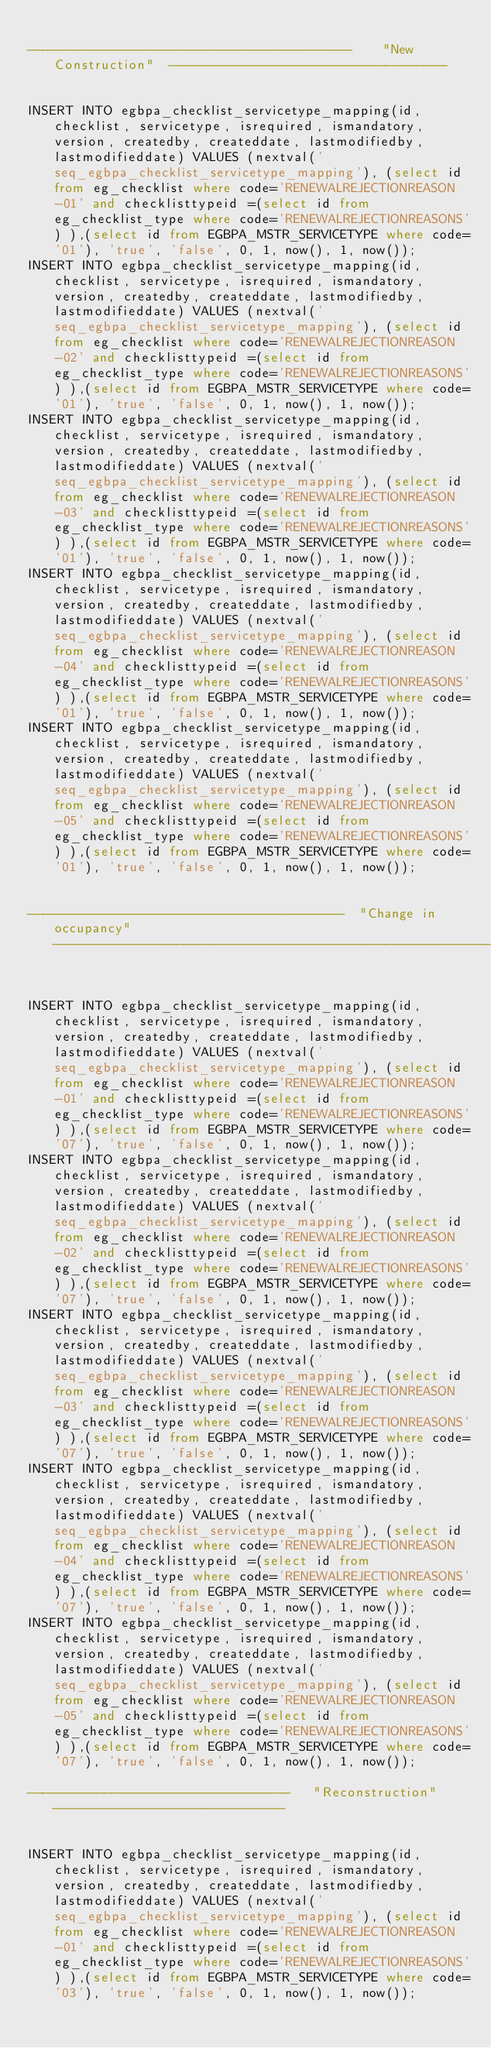Convert code to text. <code><loc_0><loc_0><loc_500><loc_500><_SQL_>
------------------------------------------    "New Construction"  ------------------------------------


INSERT INTO egbpa_checklist_servicetype_mapping(id, checklist, servicetype, isrequired, ismandatory, version, createdby, createddate, lastmodifiedby,lastmodifieddate) VALUES (nextval('seq_egbpa_checklist_servicetype_mapping'), (select id from eg_checklist where code='RENEWALREJECTIONREASON-01' and checklisttypeid =(select id from eg_checklist_type where code='RENEWALREJECTIONREASONS') ),(select id from EGBPA_MSTR_SERVICETYPE where code='01'), 'true', 'false', 0, 1, now(), 1, now());
INSERT INTO egbpa_checklist_servicetype_mapping(id, checklist, servicetype, isrequired, ismandatory, version, createdby, createddate, lastmodifiedby,lastmodifieddate) VALUES (nextval('seq_egbpa_checklist_servicetype_mapping'), (select id from eg_checklist where code='RENEWALREJECTIONREASON-02' and checklisttypeid =(select id from eg_checklist_type where code='RENEWALREJECTIONREASONS') ),(select id from EGBPA_MSTR_SERVICETYPE where code='01'), 'true', 'false', 0, 1, now(), 1, now());
INSERT INTO egbpa_checklist_servicetype_mapping(id, checklist, servicetype, isrequired, ismandatory, version, createdby, createddate, lastmodifiedby,lastmodifieddate) VALUES (nextval('seq_egbpa_checklist_servicetype_mapping'), (select id from eg_checklist where code='RENEWALREJECTIONREASON-03' and checklisttypeid =(select id from eg_checklist_type where code='RENEWALREJECTIONREASONS') ),(select id from EGBPA_MSTR_SERVICETYPE where code='01'), 'true', 'false', 0, 1, now(), 1, now());
INSERT INTO egbpa_checklist_servicetype_mapping(id, checklist, servicetype, isrequired, ismandatory, version, createdby, createddate, lastmodifiedby,lastmodifieddate) VALUES (nextval('seq_egbpa_checklist_servicetype_mapping'), (select id from eg_checklist where code='RENEWALREJECTIONREASON-04' and checklisttypeid =(select id from eg_checklist_type where code='RENEWALREJECTIONREASONS') ),(select id from EGBPA_MSTR_SERVICETYPE where code='01'), 'true', 'false', 0, 1, now(), 1, now());
INSERT INTO egbpa_checklist_servicetype_mapping(id, checklist, servicetype, isrequired, ismandatory, version, createdby, createddate, lastmodifiedby,lastmodifieddate) VALUES (nextval('seq_egbpa_checklist_servicetype_mapping'), (select id from eg_checklist where code='RENEWALREJECTIONREASON-05' and checklisttypeid =(select id from eg_checklist_type where code='RENEWALREJECTIONREASONS') ),(select id from EGBPA_MSTR_SERVICETYPE where code='01'), 'true', 'false', 0, 1, now(), 1, now());


-----------------------------------------  "Change in occupancy" -------------------------------------------------------------


INSERT INTO egbpa_checklist_servicetype_mapping(id, checklist, servicetype, isrequired, ismandatory, version, createdby, createddate, lastmodifiedby,lastmodifieddate) VALUES (nextval('seq_egbpa_checklist_servicetype_mapping'), (select id from eg_checklist where code='RENEWALREJECTIONREASON-01' and checklisttypeid =(select id from eg_checklist_type where code='RENEWALREJECTIONREASONS') ),(select id from EGBPA_MSTR_SERVICETYPE where code='07'), 'true', 'false', 0, 1, now(), 1, now());
INSERT INTO egbpa_checklist_servicetype_mapping(id, checklist, servicetype, isrequired, ismandatory, version, createdby, createddate, lastmodifiedby,lastmodifieddate) VALUES (nextval('seq_egbpa_checklist_servicetype_mapping'), (select id from eg_checklist where code='RENEWALREJECTIONREASON-02' and checklisttypeid =(select id from eg_checklist_type where code='RENEWALREJECTIONREASONS') ),(select id from EGBPA_MSTR_SERVICETYPE where code='07'), 'true', 'false', 0, 1, now(), 1, now());
INSERT INTO egbpa_checklist_servicetype_mapping(id, checklist, servicetype, isrequired, ismandatory, version, createdby, createddate, lastmodifiedby,lastmodifieddate) VALUES (nextval('seq_egbpa_checklist_servicetype_mapping'), (select id from eg_checklist where code='RENEWALREJECTIONREASON-03' and checklisttypeid =(select id from eg_checklist_type where code='RENEWALREJECTIONREASONS') ),(select id from EGBPA_MSTR_SERVICETYPE where code='07'), 'true', 'false', 0, 1, now(), 1, now());
INSERT INTO egbpa_checklist_servicetype_mapping(id, checklist, servicetype, isrequired, ismandatory, version, createdby, createddate, lastmodifiedby,lastmodifieddate) VALUES (nextval('seq_egbpa_checklist_servicetype_mapping'), (select id from eg_checklist where code='RENEWALREJECTIONREASON-04' and checklisttypeid =(select id from eg_checklist_type where code='RENEWALREJECTIONREASONS') ),(select id from EGBPA_MSTR_SERVICETYPE where code='07'), 'true', 'false', 0, 1, now(), 1, now());
INSERT INTO egbpa_checklist_servicetype_mapping(id, checklist, servicetype, isrequired, ismandatory, version, createdby, createddate, lastmodifiedby,lastmodifieddate) VALUES (nextval('seq_egbpa_checklist_servicetype_mapping'), (select id from eg_checklist where code='RENEWALREJECTIONREASON-05' and checklisttypeid =(select id from eg_checklist_type where code='RENEWALREJECTIONREASONS') ),(select id from EGBPA_MSTR_SERVICETYPE where code='07'), 'true', 'false', 0, 1, now(), 1, now());

----------------------------------   "Reconstruction"   ------------------------------


INSERT INTO egbpa_checklist_servicetype_mapping(id, checklist, servicetype, isrequired, ismandatory, version, createdby, createddate, lastmodifiedby,lastmodifieddate) VALUES (nextval('seq_egbpa_checklist_servicetype_mapping'), (select id from eg_checklist where code='RENEWALREJECTIONREASON-01' and checklisttypeid =(select id from eg_checklist_type where code='RENEWALREJECTIONREASONS') ),(select id from EGBPA_MSTR_SERVICETYPE where code='03'), 'true', 'false', 0, 1, now(), 1, now());</code> 